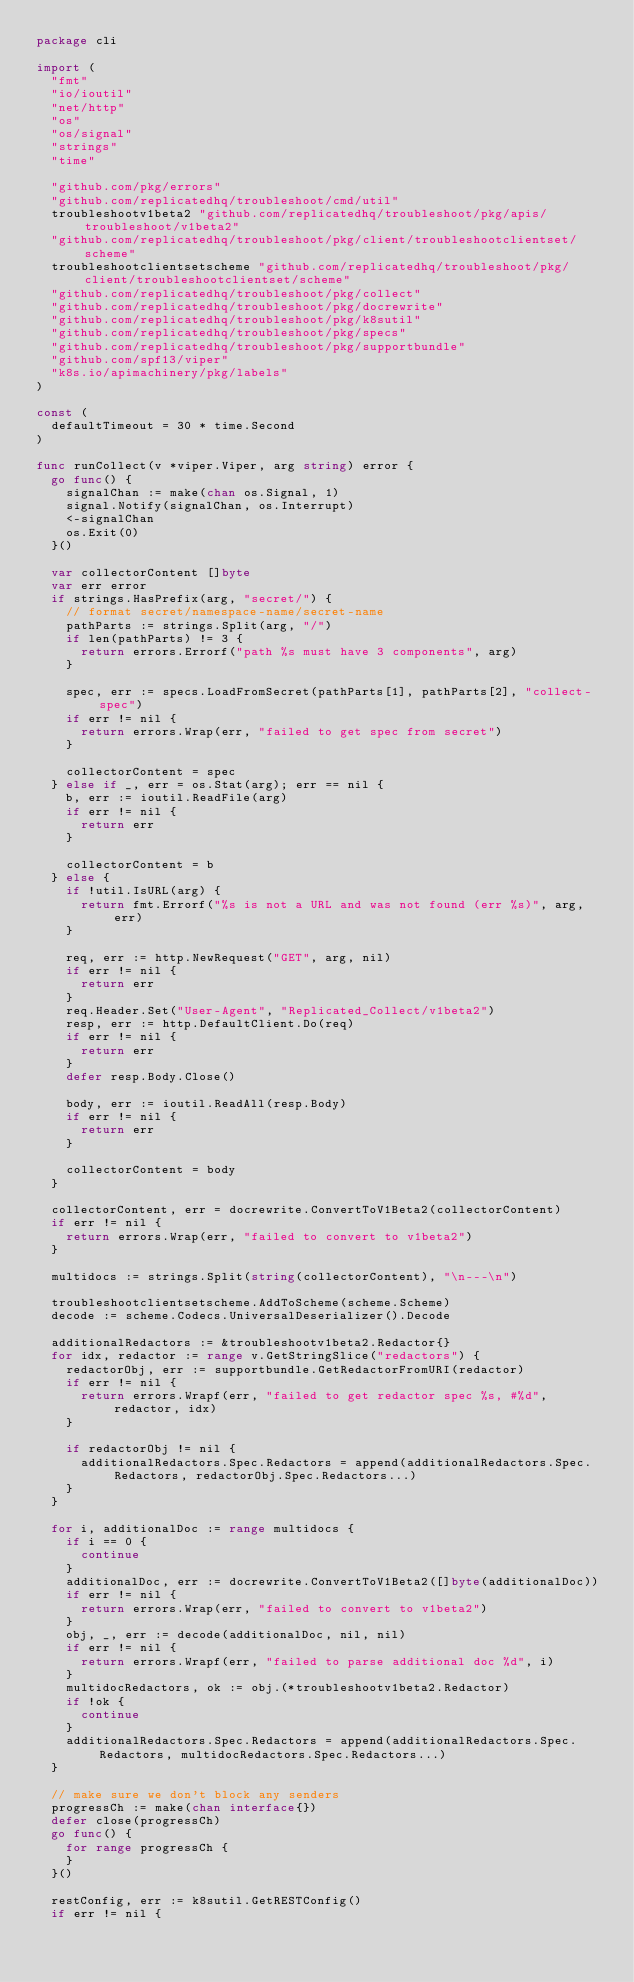Convert code to text. <code><loc_0><loc_0><loc_500><loc_500><_Go_>package cli

import (
	"fmt"
	"io/ioutil"
	"net/http"
	"os"
	"os/signal"
	"strings"
	"time"

	"github.com/pkg/errors"
	"github.com/replicatedhq/troubleshoot/cmd/util"
	troubleshootv1beta2 "github.com/replicatedhq/troubleshoot/pkg/apis/troubleshoot/v1beta2"
	"github.com/replicatedhq/troubleshoot/pkg/client/troubleshootclientset/scheme"
	troubleshootclientsetscheme "github.com/replicatedhq/troubleshoot/pkg/client/troubleshootclientset/scheme"
	"github.com/replicatedhq/troubleshoot/pkg/collect"
	"github.com/replicatedhq/troubleshoot/pkg/docrewrite"
	"github.com/replicatedhq/troubleshoot/pkg/k8sutil"
	"github.com/replicatedhq/troubleshoot/pkg/specs"
	"github.com/replicatedhq/troubleshoot/pkg/supportbundle"
	"github.com/spf13/viper"
	"k8s.io/apimachinery/pkg/labels"
)

const (
	defaultTimeout = 30 * time.Second
)

func runCollect(v *viper.Viper, arg string) error {
	go func() {
		signalChan := make(chan os.Signal, 1)
		signal.Notify(signalChan, os.Interrupt)
		<-signalChan
		os.Exit(0)
	}()

	var collectorContent []byte
	var err error
	if strings.HasPrefix(arg, "secret/") {
		// format secret/namespace-name/secret-name
		pathParts := strings.Split(arg, "/")
		if len(pathParts) != 3 {
			return errors.Errorf("path %s must have 3 components", arg)
		}

		spec, err := specs.LoadFromSecret(pathParts[1], pathParts[2], "collect-spec")
		if err != nil {
			return errors.Wrap(err, "failed to get spec from secret")
		}

		collectorContent = spec
	} else if _, err = os.Stat(arg); err == nil {
		b, err := ioutil.ReadFile(arg)
		if err != nil {
			return err
		}

		collectorContent = b
	} else {
		if !util.IsURL(arg) {
			return fmt.Errorf("%s is not a URL and was not found (err %s)", arg, err)
		}

		req, err := http.NewRequest("GET", arg, nil)
		if err != nil {
			return err
		}
		req.Header.Set("User-Agent", "Replicated_Collect/v1beta2")
		resp, err := http.DefaultClient.Do(req)
		if err != nil {
			return err
		}
		defer resp.Body.Close()

		body, err := ioutil.ReadAll(resp.Body)
		if err != nil {
			return err
		}

		collectorContent = body
	}

	collectorContent, err = docrewrite.ConvertToV1Beta2(collectorContent)
	if err != nil {
		return errors.Wrap(err, "failed to convert to v1beta2")
	}

	multidocs := strings.Split(string(collectorContent), "\n---\n")

	troubleshootclientsetscheme.AddToScheme(scheme.Scheme)
	decode := scheme.Codecs.UniversalDeserializer().Decode

	additionalRedactors := &troubleshootv1beta2.Redactor{}
	for idx, redactor := range v.GetStringSlice("redactors") {
		redactorObj, err := supportbundle.GetRedactorFromURI(redactor)
		if err != nil {
			return errors.Wrapf(err, "failed to get redactor spec %s, #%d", redactor, idx)
		}

		if redactorObj != nil {
			additionalRedactors.Spec.Redactors = append(additionalRedactors.Spec.Redactors, redactorObj.Spec.Redactors...)
		}
	}

	for i, additionalDoc := range multidocs {
		if i == 0 {
			continue
		}
		additionalDoc, err := docrewrite.ConvertToV1Beta2([]byte(additionalDoc))
		if err != nil {
			return errors.Wrap(err, "failed to convert to v1beta2")
		}
		obj, _, err := decode(additionalDoc, nil, nil)
		if err != nil {
			return errors.Wrapf(err, "failed to parse additional doc %d", i)
		}
		multidocRedactors, ok := obj.(*troubleshootv1beta2.Redactor)
		if !ok {
			continue
		}
		additionalRedactors.Spec.Redactors = append(additionalRedactors.Spec.Redactors, multidocRedactors.Spec.Redactors...)
	}

	// make sure we don't block any senders
	progressCh := make(chan interface{})
	defer close(progressCh)
	go func() {
		for range progressCh {
		}
	}()

	restConfig, err := k8sutil.GetRESTConfig()
	if err != nil {</code> 